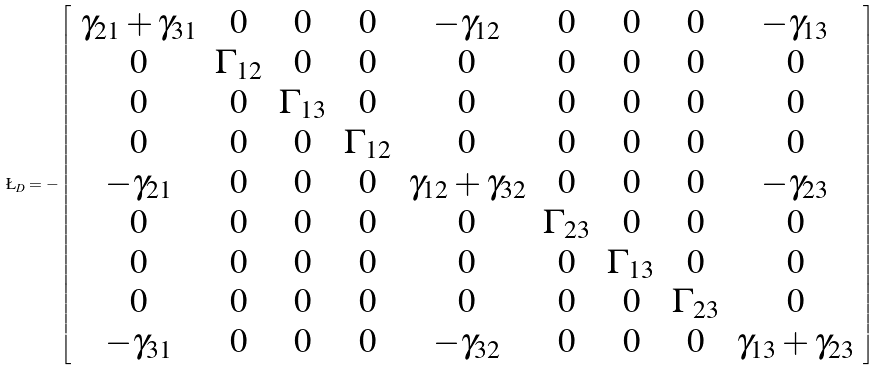Convert formula to latex. <formula><loc_0><loc_0><loc_500><loc_500>\L _ { D } = - \left [ \begin{array} { * { 9 } { c } } \gamma _ { 2 1 } + \gamma _ { 3 1 } & 0 & 0 & 0 & - \gamma _ { 1 2 } & 0 & 0 & 0 & - \gamma _ { 1 3 } \\ 0 & \Gamma _ { 1 2 } & 0 & 0 & 0 & 0 & 0 & 0 & 0 \\ 0 & 0 & \Gamma _ { 1 3 } & 0 & 0 & 0 & 0 & 0 & 0 \\ 0 & 0 & 0 & \Gamma _ { 1 2 } & 0 & 0 & 0 & 0 & 0 \\ - \gamma _ { 2 1 } & 0 & 0 & 0 & \gamma _ { 1 2 } + \gamma _ { 3 2 } & 0 & 0 & 0 & - \gamma _ { 2 3 } \\ 0 & 0 & 0 & 0 & 0 & \Gamma _ { 2 3 } & 0 & 0 & 0 \\ 0 & 0 & 0 & 0 & 0 & 0 & \Gamma _ { 1 3 } & 0 & 0 \\ 0 & 0 & 0 & 0 & 0 & 0 & 0 & \Gamma _ { 2 3 } & 0 \\ - \gamma _ { 3 1 } & 0 & 0 & 0 & - \gamma _ { 3 2 } & 0 & 0 & 0 & \gamma _ { 1 3 } + \gamma _ { 2 3 } \end{array} \right ]</formula> 